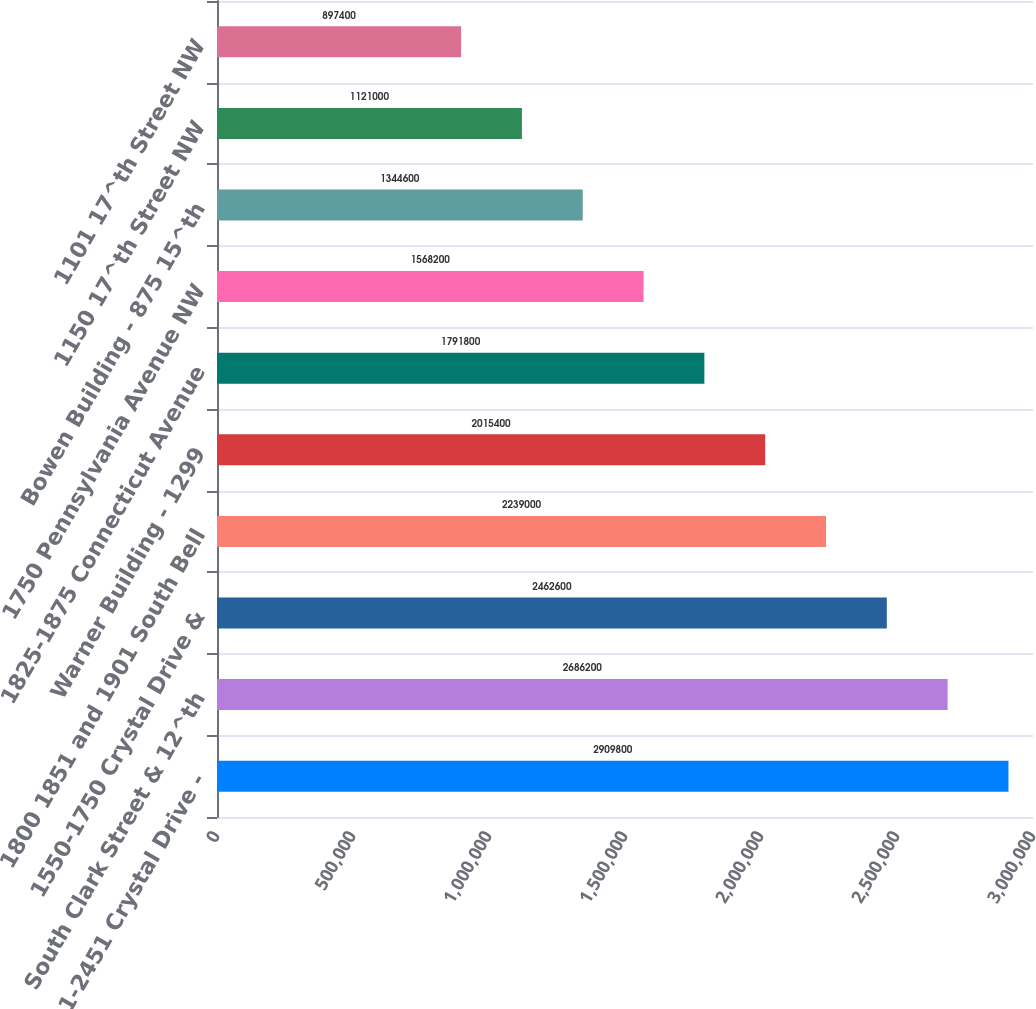<chart> <loc_0><loc_0><loc_500><loc_500><bar_chart><fcel>2011-2451 Crystal Drive -<fcel>South Clark Street & 12^th<fcel>1550-1750 Crystal Drive &<fcel>1800 1851 and 1901 South Bell<fcel>Warner Building - 1299<fcel>1825-1875 Connecticut Avenue<fcel>1750 Pennsylvania Avenue NW<fcel>Bowen Building - 875 15^th<fcel>1150 17^th Street NW<fcel>1101 17^th Street NW<nl><fcel>2.9098e+06<fcel>2.6862e+06<fcel>2.4626e+06<fcel>2.239e+06<fcel>2.0154e+06<fcel>1.7918e+06<fcel>1.5682e+06<fcel>1.3446e+06<fcel>1.121e+06<fcel>897400<nl></chart> 